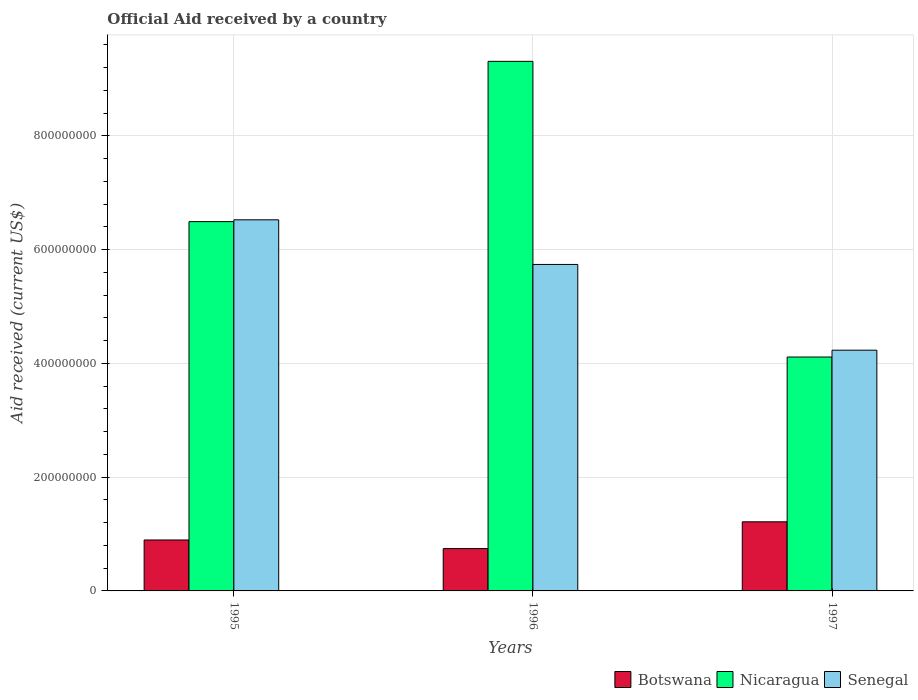How many different coloured bars are there?
Provide a short and direct response. 3. How many groups of bars are there?
Your answer should be compact. 3. Are the number of bars on each tick of the X-axis equal?
Ensure brevity in your answer.  Yes. How many bars are there on the 2nd tick from the left?
Make the answer very short. 3. In how many cases, is the number of bars for a given year not equal to the number of legend labels?
Your answer should be very brief. 0. What is the net official aid received in Botswana in 1997?
Provide a succinct answer. 1.22e+08. Across all years, what is the maximum net official aid received in Botswana?
Offer a very short reply. 1.22e+08. Across all years, what is the minimum net official aid received in Nicaragua?
Give a very brief answer. 4.11e+08. In which year was the net official aid received in Botswana minimum?
Provide a short and direct response. 1996. What is the total net official aid received in Senegal in the graph?
Offer a terse response. 1.65e+09. What is the difference between the net official aid received in Senegal in 1996 and that in 1997?
Make the answer very short. 1.51e+08. What is the difference between the net official aid received in Senegal in 1997 and the net official aid received in Nicaragua in 1996?
Your answer should be very brief. -5.08e+08. What is the average net official aid received in Nicaragua per year?
Provide a succinct answer. 6.64e+08. In the year 1997, what is the difference between the net official aid received in Botswana and net official aid received in Nicaragua?
Provide a succinct answer. -2.90e+08. What is the ratio of the net official aid received in Senegal in 1995 to that in 1997?
Offer a terse response. 1.54. Is the difference between the net official aid received in Botswana in 1995 and 1996 greater than the difference between the net official aid received in Nicaragua in 1995 and 1996?
Offer a terse response. Yes. What is the difference between the highest and the second highest net official aid received in Botswana?
Provide a succinct answer. 3.20e+07. What is the difference between the highest and the lowest net official aid received in Nicaragua?
Your response must be concise. 5.20e+08. In how many years, is the net official aid received in Botswana greater than the average net official aid received in Botswana taken over all years?
Make the answer very short. 1. What does the 2nd bar from the left in 1997 represents?
Offer a terse response. Nicaragua. What does the 3rd bar from the right in 1995 represents?
Ensure brevity in your answer.  Botswana. Is it the case that in every year, the sum of the net official aid received in Botswana and net official aid received in Nicaragua is greater than the net official aid received in Senegal?
Provide a short and direct response. Yes. How many bars are there?
Keep it short and to the point. 9. What is the difference between two consecutive major ticks on the Y-axis?
Offer a very short reply. 2.00e+08. Does the graph contain grids?
Your answer should be compact. Yes. Where does the legend appear in the graph?
Provide a short and direct response. Bottom right. How many legend labels are there?
Ensure brevity in your answer.  3. What is the title of the graph?
Your answer should be very brief. Official Aid received by a country. Does "Indonesia" appear as one of the legend labels in the graph?
Give a very brief answer. No. What is the label or title of the X-axis?
Give a very brief answer. Years. What is the label or title of the Y-axis?
Your answer should be very brief. Aid received (current US$). What is the Aid received (current US$) in Botswana in 1995?
Your answer should be compact. 8.95e+07. What is the Aid received (current US$) in Nicaragua in 1995?
Your response must be concise. 6.49e+08. What is the Aid received (current US$) of Senegal in 1995?
Provide a short and direct response. 6.52e+08. What is the Aid received (current US$) in Botswana in 1996?
Ensure brevity in your answer.  7.44e+07. What is the Aid received (current US$) of Nicaragua in 1996?
Offer a very short reply. 9.31e+08. What is the Aid received (current US$) of Senegal in 1996?
Your answer should be very brief. 5.74e+08. What is the Aid received (current US$) in Botswana in 1997?
Provide a short and direct response. 1.22e+08. What is the Aid received (current US$) in Nicaragua in 1997?
Provide a short and direct response. 4.11e+08. What is the Aid received (current US$) in Senegal in 1997?
Your answer should be compact. 4.23e+08. Across all years, what is the maximum Aid received (current US$) of Botswana?
Your answer should be compact. 1.22e+08. Across all years, what is the maximum Aid received (current US$) of Nicaragua?
Your response must be concise. 9.31e+08. Across all years, what is the maximum Aid received (current US$) of Senegal?
Make the answer very short. 6.52e+08. Across all years, what is the minimum Aid received (current US$) in Botswana?
Provide a short and direct response. 7.44e+07. Across all years, what is the minimum Aid received (current US$) of Nicaragua?
Ensure brevity in your answer.  4.11e+08. Across all years, what is the minimum Aid received (current US$) of Senegal?
Give a very brief answer. 4.23e+08. What is the total Aid received (current US$) in Botswana in the graph?
Provide a succinct answer. 2.85e+08. What is the total Aid received (current US$) of Nicaragua in the graph?
Keep it short and to the point. 1.99e+09. What is the total Aid received (current US$) in Senegal in the graph?
Give a very brief answer. 1.65e+09. What is the difference between the Aid received (current US$) of Botswana in 1995 and that in 1996?
Keep it short and to the point. 1.51e+07. What is the difference between the Aid received (current US$) of Nicaragua in 1995 and that in 1996?
Ensure brevity in your answer.  -2.82e+08. What is the difference between the Aid received (current US$) in Senegal in 1995 and that in 1996?
Your answer should be very brief. 7.85e+07. What is the difference between the Aid received (current US$) of Botswana in 1995 and that in 1997?
Provide a short and direct response. -3.20e+07. What is the difference between the Aid received (current US$) in Nicaragua in 1995 and that in 1997?
Your answer should be compact. 2.38e+08. What is the difference between the Aid received (current US$) in Senegal in 1995 and that in 1997?
Your answer should be compact. 2.29e+08. What is the difference between the Aid received (current US$) in Botswana in 1996 and that in 1997?
Offer a terse response. -4.70e+07. What is the difference between the Aid received (current US$) of Nicaragua in 1996 and that in 1997?
Your response must be concise. 5.20e+08. What is the difference between the Aid received (current US$) in Senegal in 1996 and that in 1997?
Make the answer very short. 1.51e+08. What is the difference between the Aid received (current US$) of Botswana in 1995 and the Aid received (current US$) of Nicaragua in 1996?
Offer a terse response. -8.41e+08. What is the difference between the Aid received (current US$) of Botswana in 1995 and the Aid received (current US$) of Senegal in 1996?
Your answer should be compact. -4.84e+08. What is the difference between the Aid received (current US$) of Nicaragua in 1995 and the Aid received (current US$) of Senegal in 1996?
Give a very brief answer. 7.52e+07. What is the difference between the Aid received (current US$) in Botswana in 1995 and the Aid received (current US$) in Nicaragua in 1997?
Keep it short and to the point. -3.22e+08. What is the difference between the Aid received (current US$) in Botswana in 1995 and the Aid received (current US$) in Senegal in 1997?
Offer a terse response. -3.34e+08. What is the difference between the Aid received (current US$) in Nicaragua in 1995 and the Aid received (current US$) in Senegal in 1997?
Offer a terse response. 2.26e+08. What is the difference between the Aid received (current US$) of Botswana in 1996 and the Aid received (current US$) of Nicaragua in 1997?
Your answer should be very brief. -3.37e+08. What is the difference between the Aid received (current US$) of Botswana in 1996 and the Aid received (current US$) of Senegal in 1997?
Your response must be concise. -3.49e+08. What is the difference between the Aid received (current US$) of Nicaragua in 1996 and the Aid received (current US$) of Senegal in 1997?
Your answer should be compact. 5.08e+08. What is the average Aid received (current US$) of Botswana per year?
Give a very brief answer. 9.52e+07. What is the average Aid received (current US$) in Nicaragua per year?
Your answer should be compact. 6.64e+08. What is the average Aid received (current US$) in Senegal per year?
Provide a succinct answer. 5.50e+08. In the year 1995, what is the difference between the Aid received (current US$) in Botswana and Aid received (current US$) in Nicaragua?
Ensure brevity in your answer.  -5.60e+08. In the year 1995, what is the difference between the Aid received (current US$) of Botswana and Aid received (current US$) of Senegal?
Keep it short and to the point. -5.63e+08. In the year 1995, what is the difference between the Aid received (current US$) in Nicaragua and Aid received (current US$) in Senegal?
Give a very brief answer. -3.21e+06. In the year 1996, what is the difference between the Aid received (current US$) in Botswana and Aid received (current US$) in Nicaragua?
Provide a succinct answer. -8.56e+08. In the year 1996, what is the difference between the Aid received (current US$) in Botswana and Aid received (current US$) in Senegal?
Offer a very short reply. -4.99e+08. In the year 1996, what is the difference between the Aid received (current US$) of Nicaragua and Aid received (current US$) of Senegal?
Keep it short and to the point. 3.57e+08. In the year 1997, what is the difference between the Aid received (current US$) in Botswana and Aid received (current US$) in Nicaragua?
Offer a terse response. -2.90e+08. In the year 1997, what is the difference between the Aid received (current US$) of Botswana and Aid received (current US$) of Senegal?
Provide a succinct answer. -3.02e+08. In the year 1997, what is the difference between the Aid received (current US$) in Nicaragua and Aid received (current US$) in Senegal?
Give a very brief answer. -1.20e+07. What is the ratio of the Aid received (current US$) of Botswana in 1995 to that in 1996?
Offer a terse response. 1.2. What is the ratio of the Aid received (current US$) of Nicaragua in 1995 to that in 1996?
Make the answer very short. 0.7. What is the ratio of the Aid received (current US$) of Senegal in 1995 to that in 1996?
Provide a succinct answer. 1.14. What is the ratio of the Aid received (current US$) of Botswana in 1995 to that in 1997?
Your answer should be compact. 0.74. What is the ratio of the Aid received (current US$) in Nicaragua in 1995 to that in 1997?
Your response must be concise. 1.58. What is the ratio of the Aid received (current US$) in Senegal in 1995 to that in 1997?
Ensure brevity in your answer.  1.54. What is the ratio of the Aid received (current US$) in Botswana in 1996 to that in 1997?
Give a very brief answer. 0.61. What is the ratio of the Aid received (current US$) in Nicaragua in 1996 to that in 1997?
Your answer should be very brief. 2.26. What is the ratio of the Aid received (current US$) of Senegal in 1996 to that in 1997?
Offer a very short reply. 1.36. What is the difference between the highest and the second highest Aid received (current US$) of Botswana?
Your response must be concise. 3.20e+07. What is the difference between the highest and the second highest Aid received (current US$) of Nicaragua?
Your answer should be very brief. 2.82e+08. What is the difference between the highest and the second highest Aid received (current US$) of Senegal?
Give a very brief answer. 7.85e+07. What is the difference between the highest and the lowest Aid received (current US$) of Botswana?
Your answer should be compact. 4.70e+07. What is the difference between the highest and the lowest Aid received (current US$) in Nicaragua?
Offer a very short reply. 5.20e+08. What is the difference between the highest and the lowest Aid received (current US$) of Senegal?
Make the answer very short. 2.29e+08. 